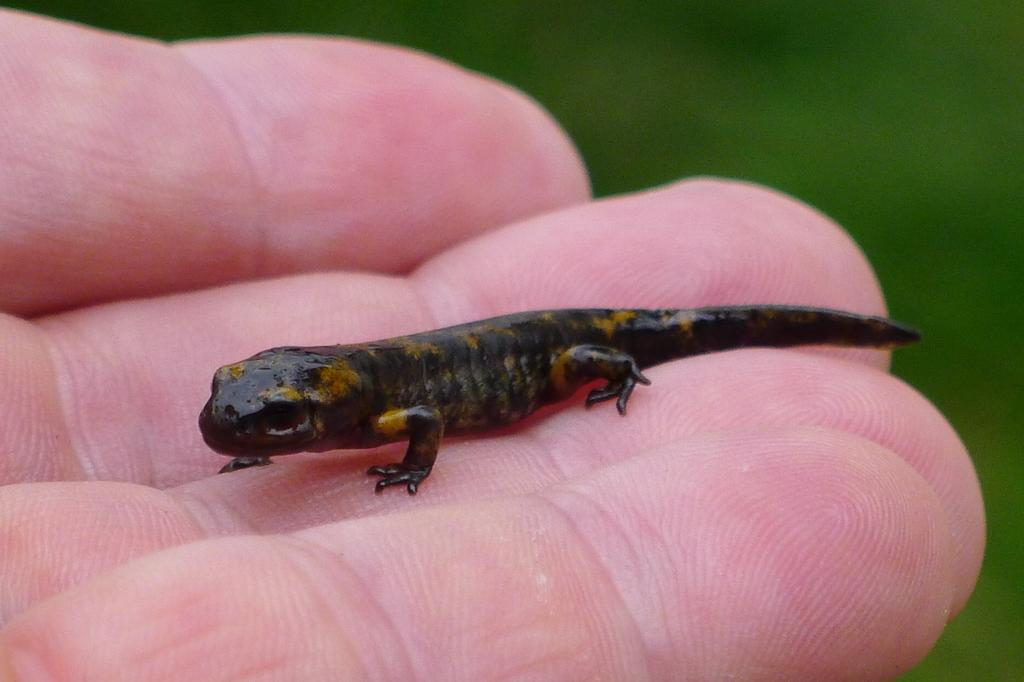What type of animal is in the picture? There is a small black color lizard in the picture. How is the lizard being held in the image? There is a person holding the lizard in his hand. What type of material is the bike made of in the image? There is no bike present in the image; it only features a person holding a small black color lizard. 